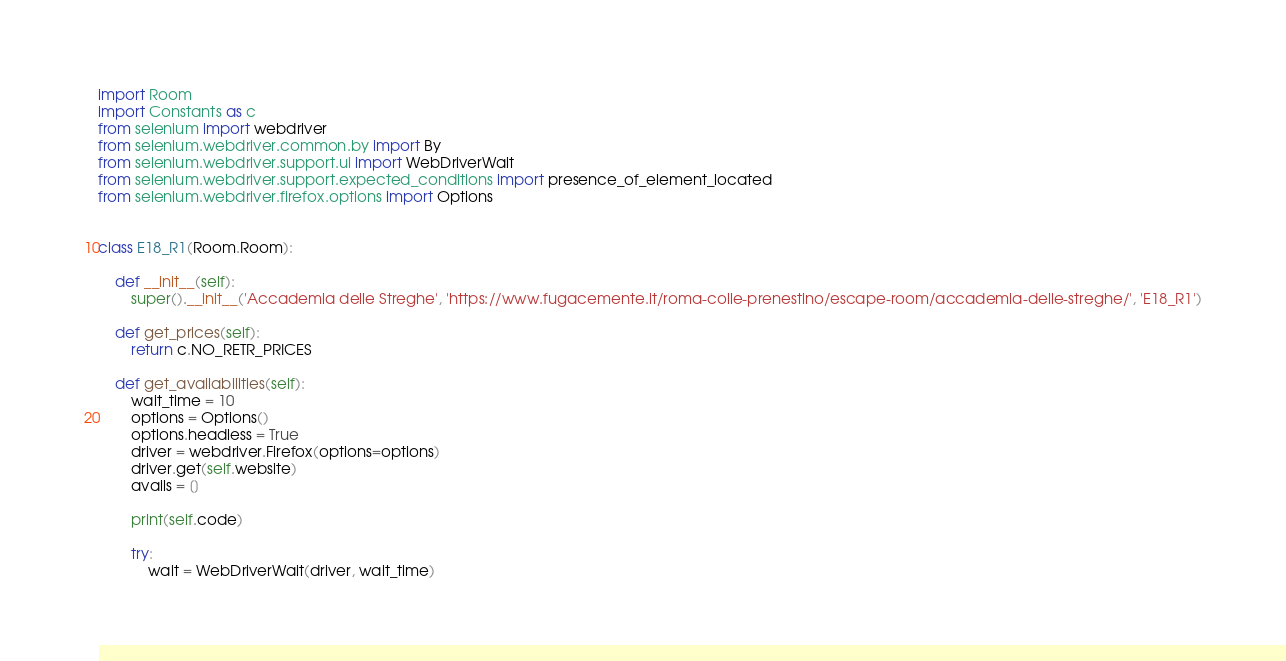<code> <loc_0><loc_0><loc_500><loc_500><_Python_>import Room
import Constants as c
from selenium import webdriver
from selenium.webdriver.common.by import By
from selenium.webdriver.support.ui import WebDriverWait
from selenium.webdriver.support.expected_conditions import presence_of_element_located
from selenium.webdriver.firefox.options import Options


class E18_R1(Room.Room):

    def __init__(self):
        super().__init__('Accademia delle Streghe', 'https://www.fugacemente.it/roma-colle-prenestino/escape-room/accademia-delle-streghe/', 'E18_R1')

    def get_prices(self):
        return c.NO_RETR_PRICES

    def get_availabilities(self):
        wait_time = 10
        options = Options()
        options.headless = True
        driver = webdriver.Firefox(options=options)
        driver.get(self.website)
        avails = []

        print(self.code)

        try:
            wait = WebDriverWait(driver, wait_time)</code> 